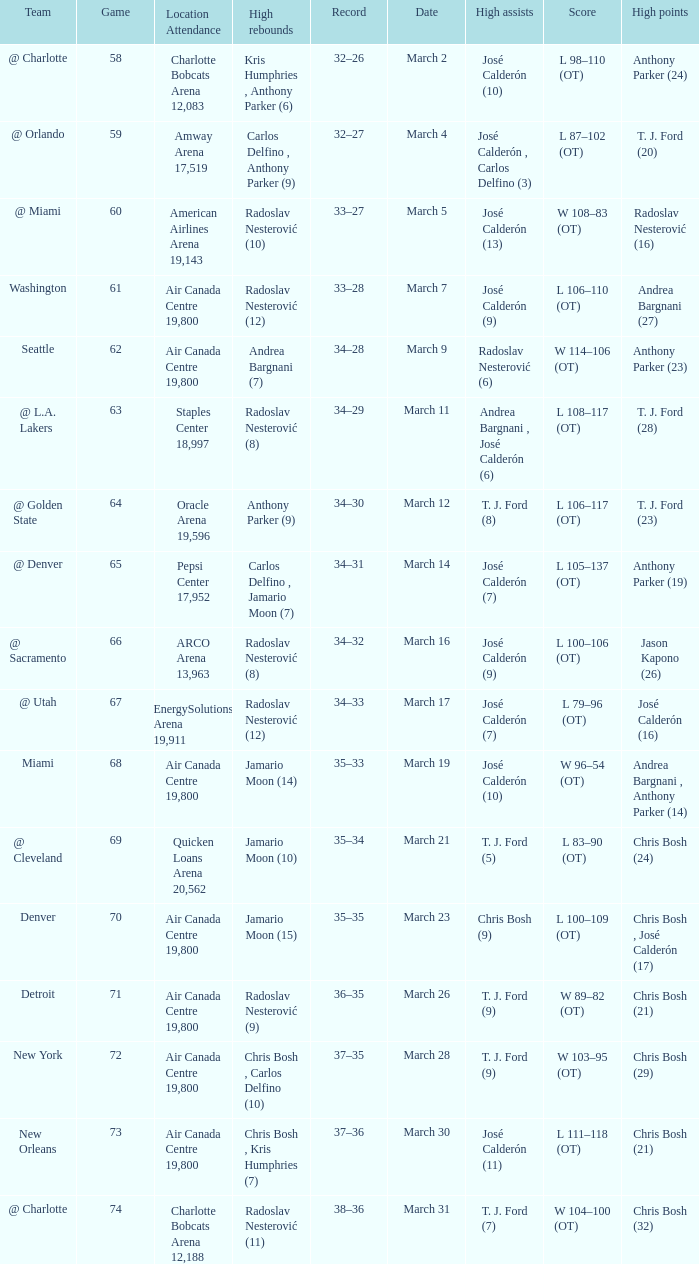How many attended the game on march 16 after over 64 games? ARCO Arena 13,963. 